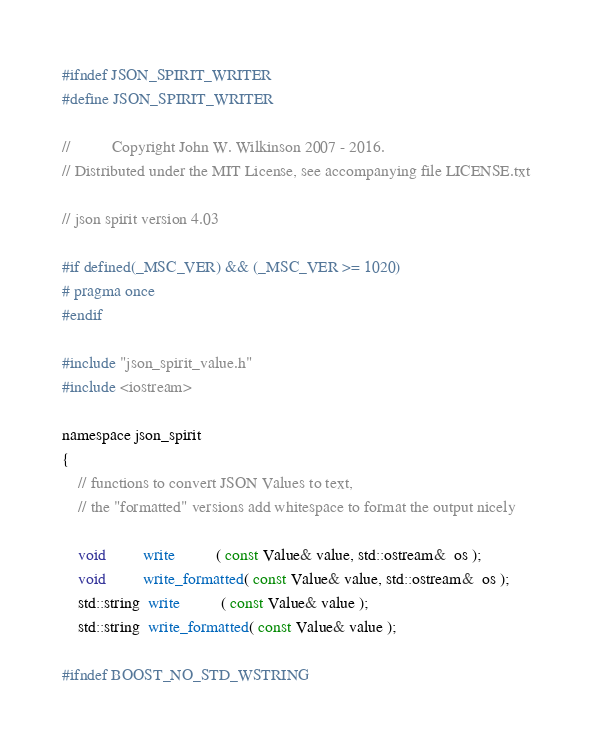Convert code to text. <code><loc_0><loc_0><loc_500><loc_500><_C_>#ifndef JSON_SPIRIT_WRITER
#define JSON_SPIRIT_WRITER

//          Copyright John W. Wilkinson 2007 - 2016.
// Distributed under the MIT License, see accompanying file LICENSE.txt

// json spirit version 4.03

#if defined(_MSC_VER) && (_MSC_VER >= 1020)
# pragma once
#endif

#include "json_spirit_value.h"
#include <iostream>

namespace json_spirit
{
    // functions to convert JSON Values to text, 
    // the "formatted" versions add whitespace to format the output nicely

    void         write          ( const Value& value, std::ostream&  os );
    void         write_formatted( const Value& value, std::ostream&  os );
    std::string  write          ( const Value& value );
    std::string  write_formatted( const Value& value );

#ifndef BOOST_NO_STD_WSTRING
</code> 